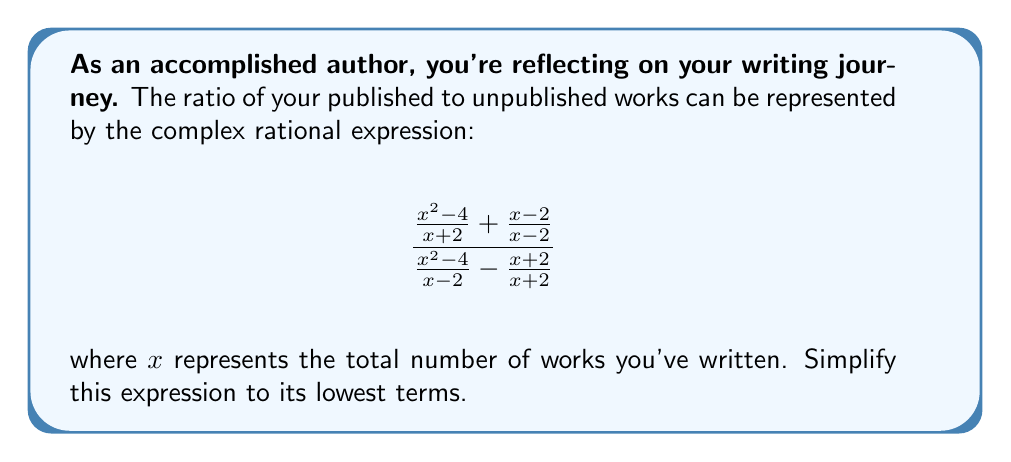Teach me how to tackle this problem. Let's simplify this complex rational expression step by step:

1) First, let's simplify the numerator and denominator separately.

   Numerator: $\frac{x^2 - 4}{x + 2} + \frac{x - 2}{x - 2}$
   
   $= \frac{x^2 - 4}{x + 2} + 1$ (since $\frac{x - 2}{x - 2} = 1$)
   
   $= \frac{x^2 - 4 + x + 2}{x + 2}$
   
   $= \frac{x^2 + x - 2}{x + 2}$

   Denominator: $\frac{x^2 - 4}{x - 2} - \frac{x + 2}{x + 2}$
   
   $= \frac{x^2 - 4}{x - 2} - 1$
   
   $= \frac{x^2 - 4 - x + 2}{x - 2}$
   
   $= \frac{x^2 - x - 2}{x - 2}$

2) Now our expression looks like this:

   $$\frac{\frac{x^2 + x - 2}{x + 2}}{\frac{x^2 - x - 2}{x - 2}}$$

3) To divide fractions, we multiply by the reciprocal:

   $$\frac{x^2 + x - 2}{x + 2} \cdot \frac{x - 2}{x^2 - x - 2}$$

4) Multiply numerators and denominators:

   $$\frac{(x^2 + x - 2)(x - 2)}{(x + 2)(x^2 - x - 2)}$$

5) Expand the numerator:
   
   $x^3 - 2x^2 + x^2 - 2x - 2x + 4 = x^3 - x^2 - 4x + 4$

6) The denominator doesn't need expansion. So our expression is now:

   $$\frac{x^3 - x^2 - 4x + 4}{(x + 2)(x^2 - x - 2)}$$

7) Factor out the greatest common factor in both numerator and denominator:

   Numerator: $x^3 - x^2 - 4x + 4 = (x - 2)(x^2 + x - 2)$
   Denominator: $(x + 2)(x^2 - x - 2) = (x + 2)(x - 2)(x + 1)$

8) Cancel out the common factor $(x - 2)$:

   $$\frac{x^2 + x - 2}{(x + 2)(x + 1)}$$

This is the simplified expression in its lowest terms.
Answer: $\frac{x^2 + x - 2}{(x + 2)(x + 1)}$ 